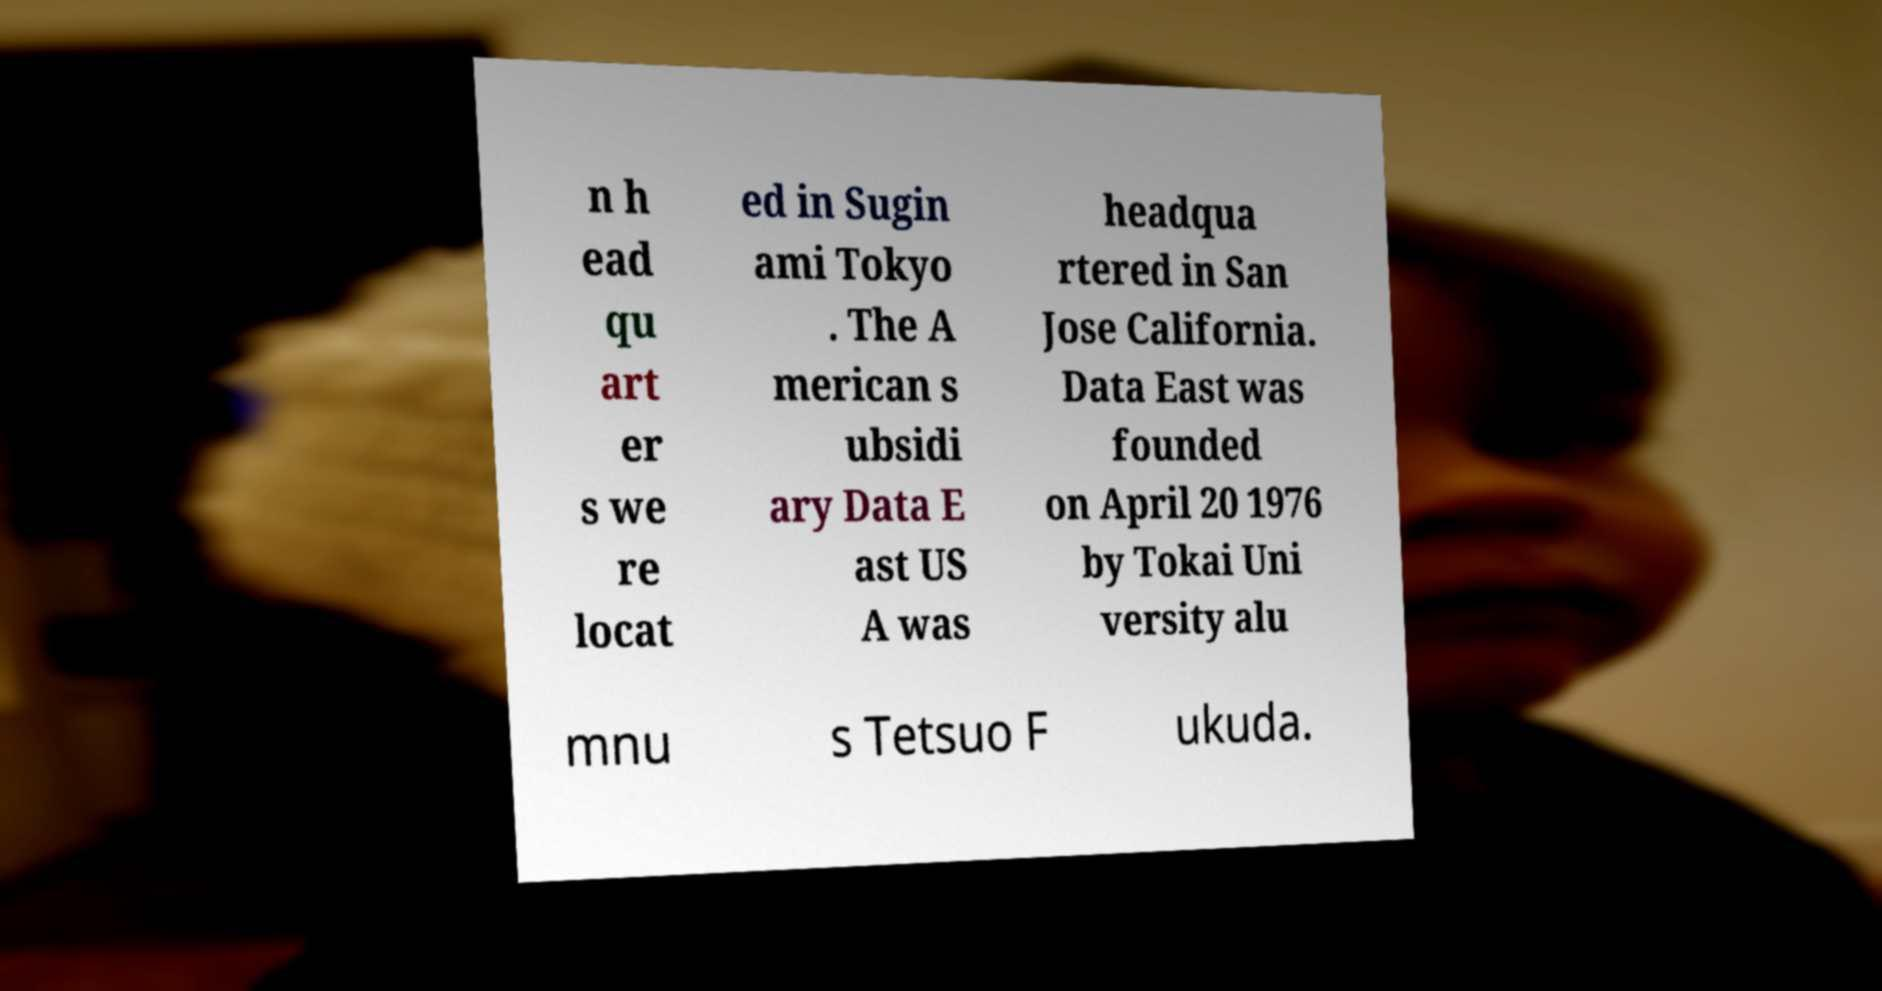Could you extract and type out the text from this image? n h ead qu art er s we re locat ed in Sugin ami Tokyo . The A merican s ubsidi ary Data E ast US A was headqua rtered in San Jose California. Data East was founded on April 20 1976 by Tokai Uni versity alu mnu s Tetsuo F ukuda. 